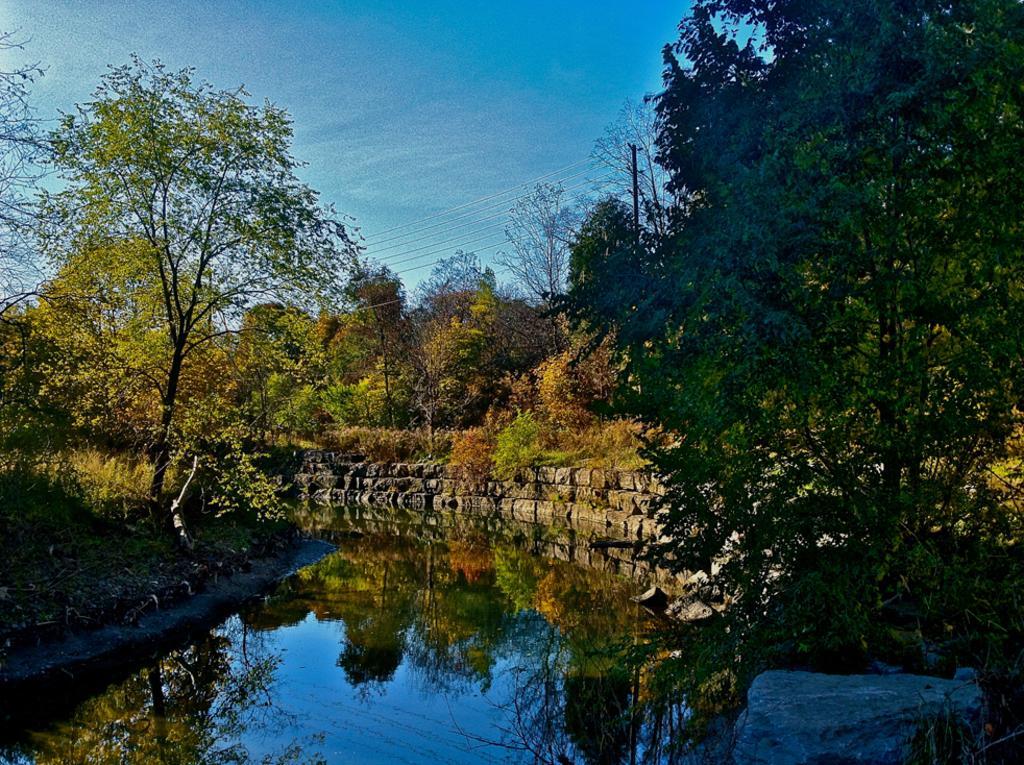Describe this image in one or two sentences. In this picture there is water and there are few trees and a greenery ground on either sides of it. 